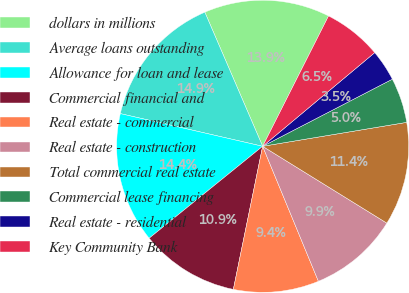Convert chart. <chart><loc_0><loc_0><loc_500><loc_500><pie_chart><fcel>dollars in millions<fcel>Average loans outstanding<fcel>Allowance for loan and lease<fcel>Commercial financial and<fcel>Real estate - commercial<fcel>Real estate - construction<fcel>Total commercial real estate<fcel>Commercial lease financing<fcel>Real estate - residential<fcel>Key Community Bank<nl><fcel>13.93%<fcel>14.93%<fcel>14.43%<fcel>10.95%<fcel>9.45%<fcel>9.95%<fcel>11.44%<fcel>4.98%<fcel>3.48%<fcel>6.47%<nl></chart> 